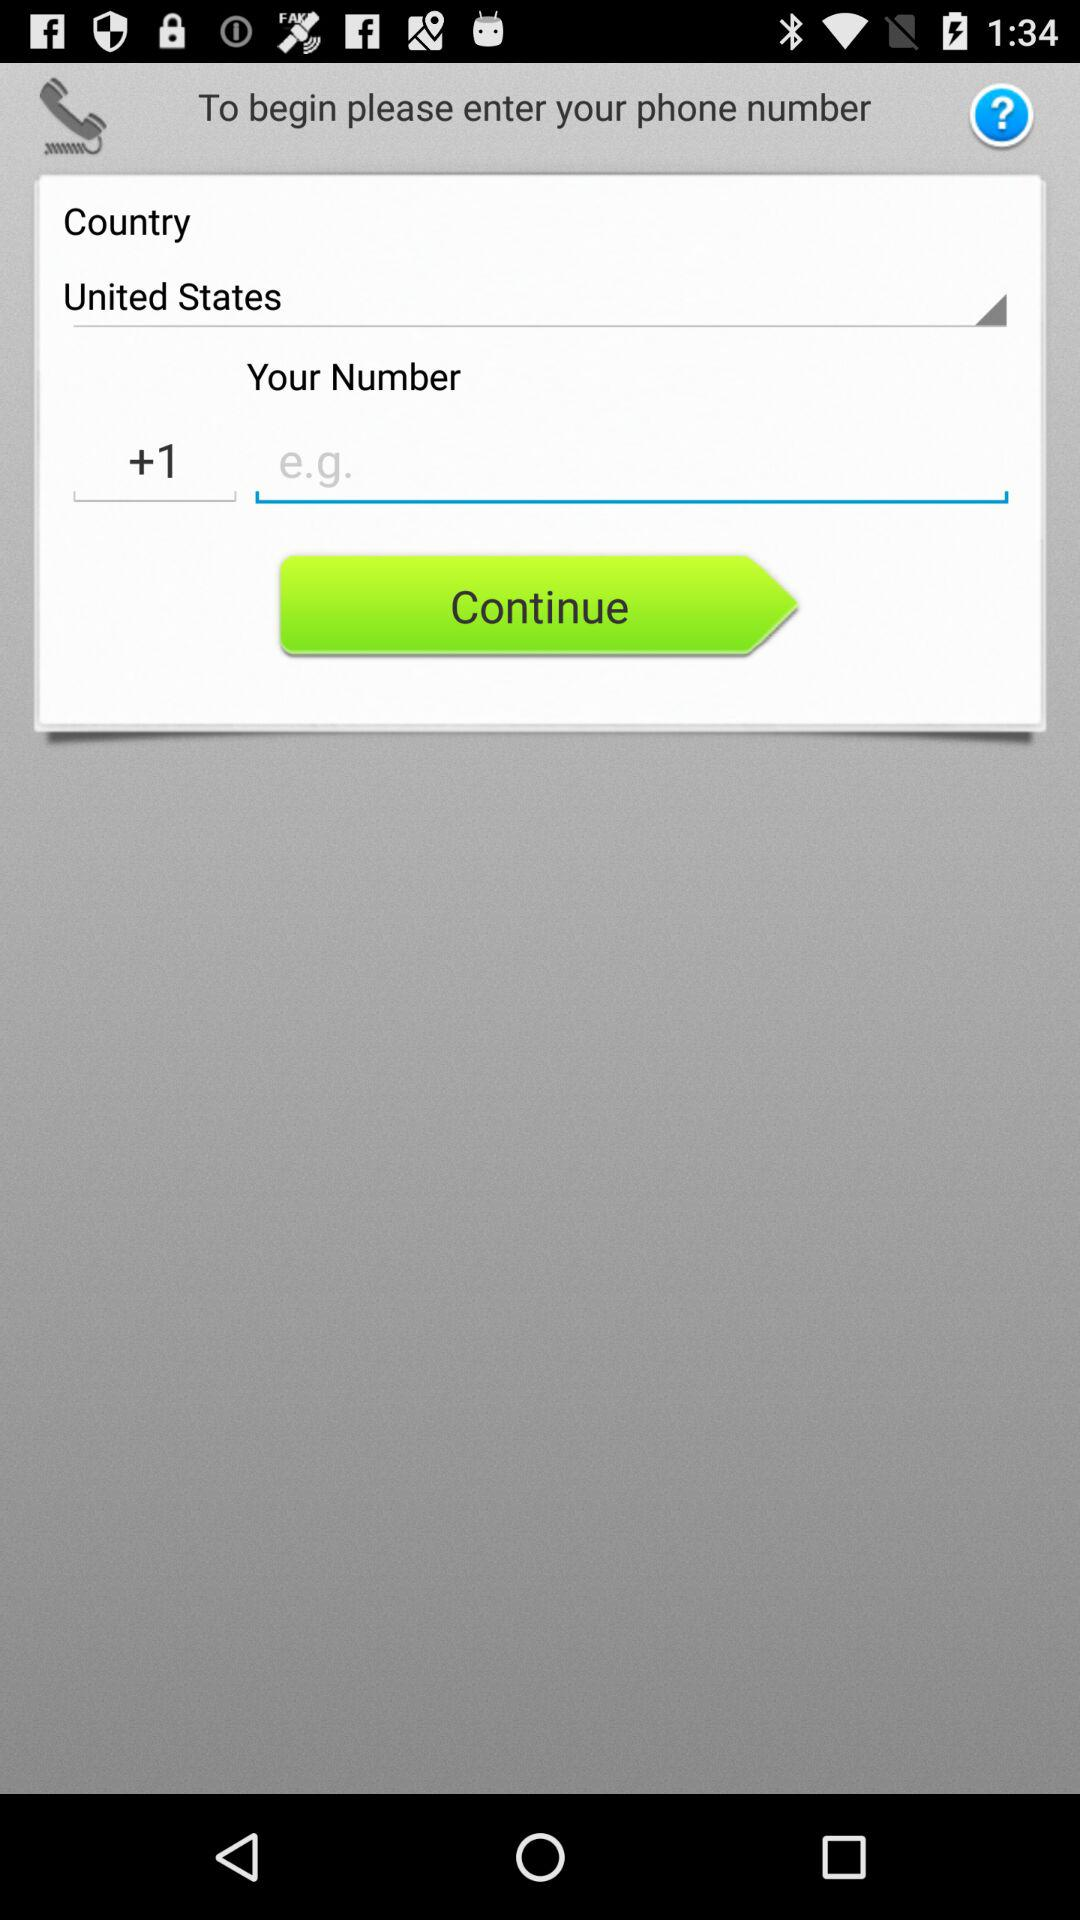What is the name of the country? The name of the country is United States. 